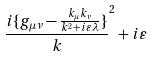Convert formula to latex. <formula><loc_0><loc_0><loc_500><loc_500>\frac { i \{ g _ { \mu \nu } - \frac { k _ { \mu } k _ { \nu } } { k ^ { 2 } + i \varepsilon \lambda } \} } k ^ { 2 } + i \varepsilon</formula> 